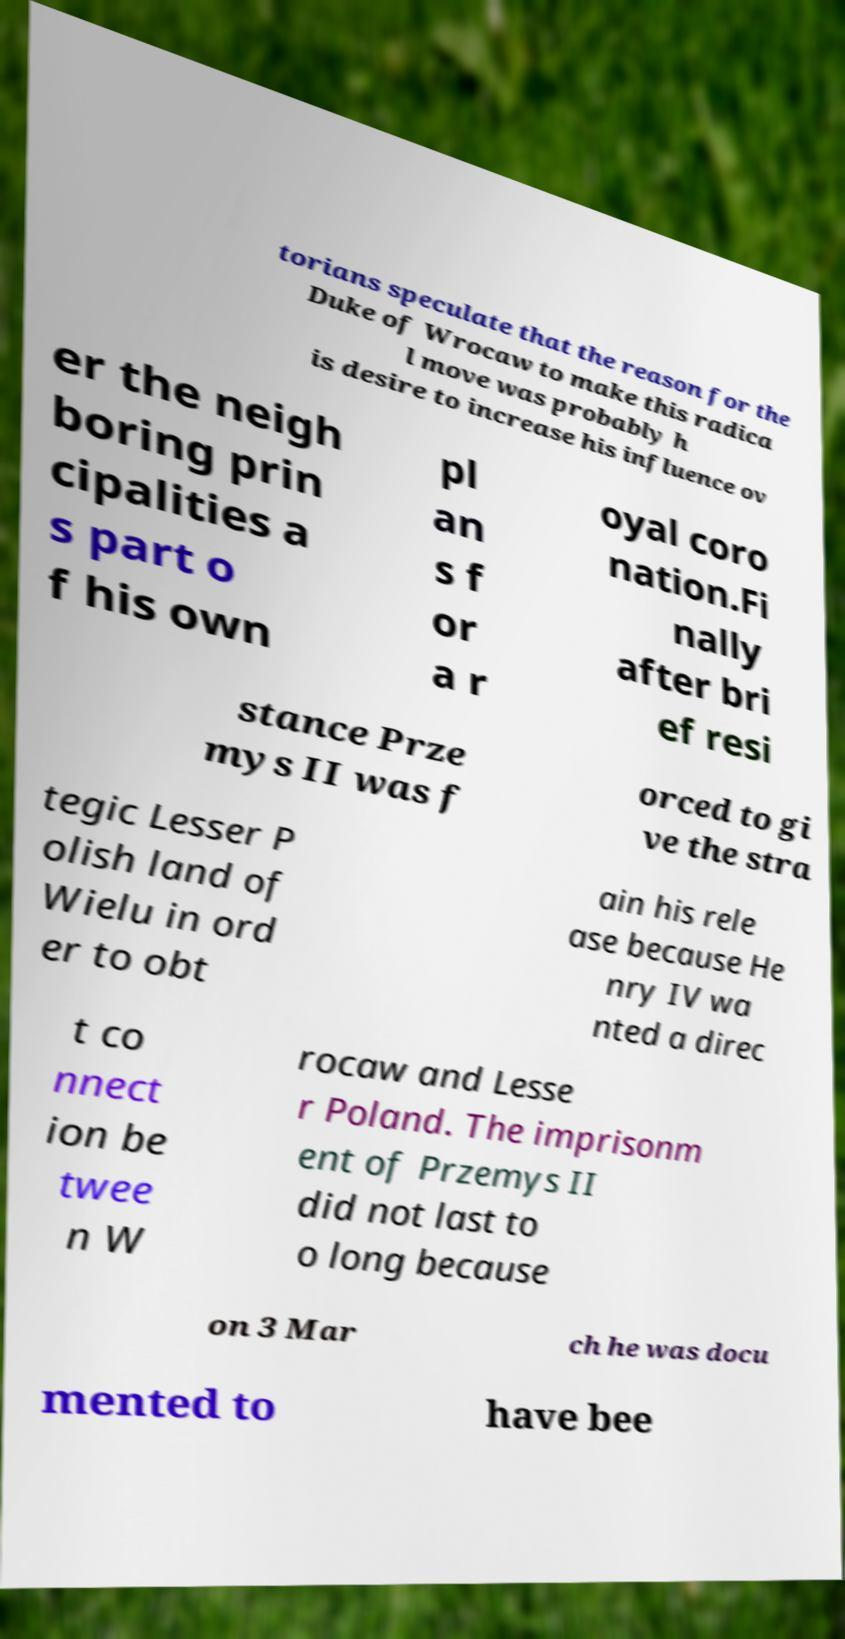For documentation purposes, I need the text within this image transcribed. Could you provide that? torians speculate that the reason for the Duke of Wrocaw to make this radica l move was probably h is desire to increase his influence ov er the neigh boring prin cipalities a s part o f his own pl an s f or a r oyal coro nation.Fi nally after bri ef resi stance Prze mys II was f orced to gi ve the stra tegic Lesser P olish land of Wielu in ord er to obt ain his rele ase because He nry IV wa nted a direc t co nnect ion be twee n W rocaw and Lesse r Poland. The imprisonm ent of Przemys II did not last to o long because on 3 Mar ch he was docu mented to have bee 